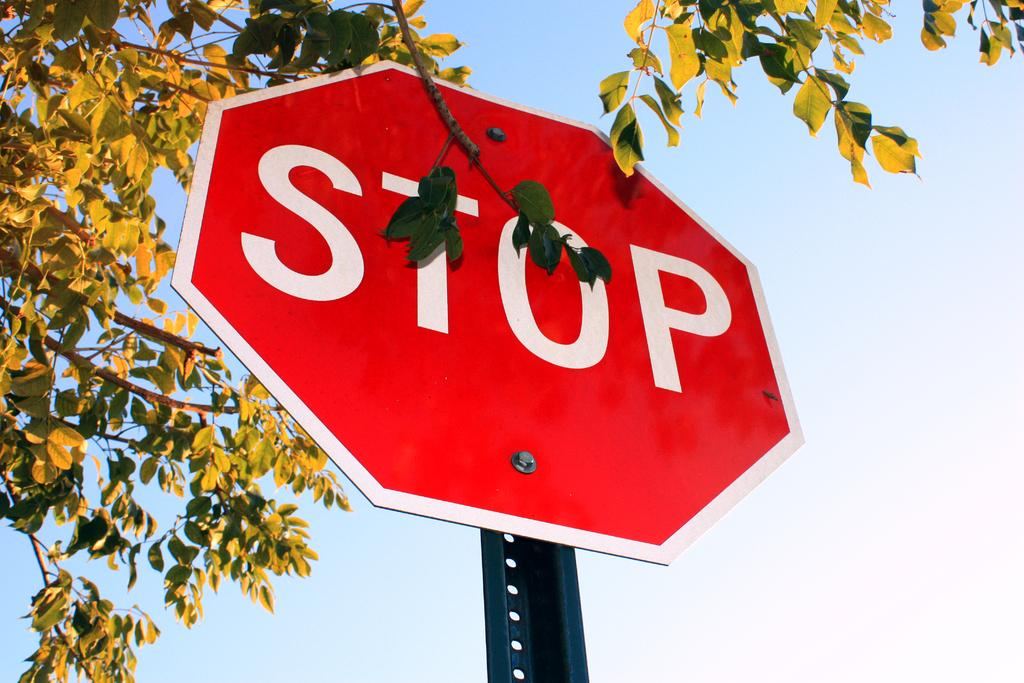<image>
Describe the image concisely. A bright red sign has the word "STOP" on it in white letters. 